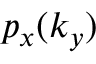<formula> <loc_0><loc_0><loc_500><loc_500>p _ { x } ( k _ { y } )</formula> 